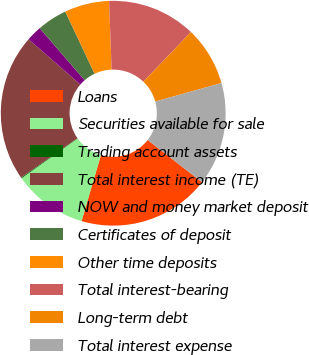Convert chart. <chart><loc_0><loc_0><loc_500><loc_500><pie_chart><fcel>Loans<fcel>Securities available for sale<fcel>Trading account assets<fcel>Total interest income (TE)<fcel>NOW and money market deposit<fcel>Certificates of deposit<fcel>Other time deposits<fcel>Total interest-bearing<fcel>Long-term debt<fcel>Total interest expense<nl><fcel>19.04%<fcel>10.63%<fcel>0.12%<fcel>21.14%<fcel>2.22%<fcel>4.33%<fcel>6.43%<fcel>12.73%<fcel>8.53%<fcel>14.83%<nl></chart> 